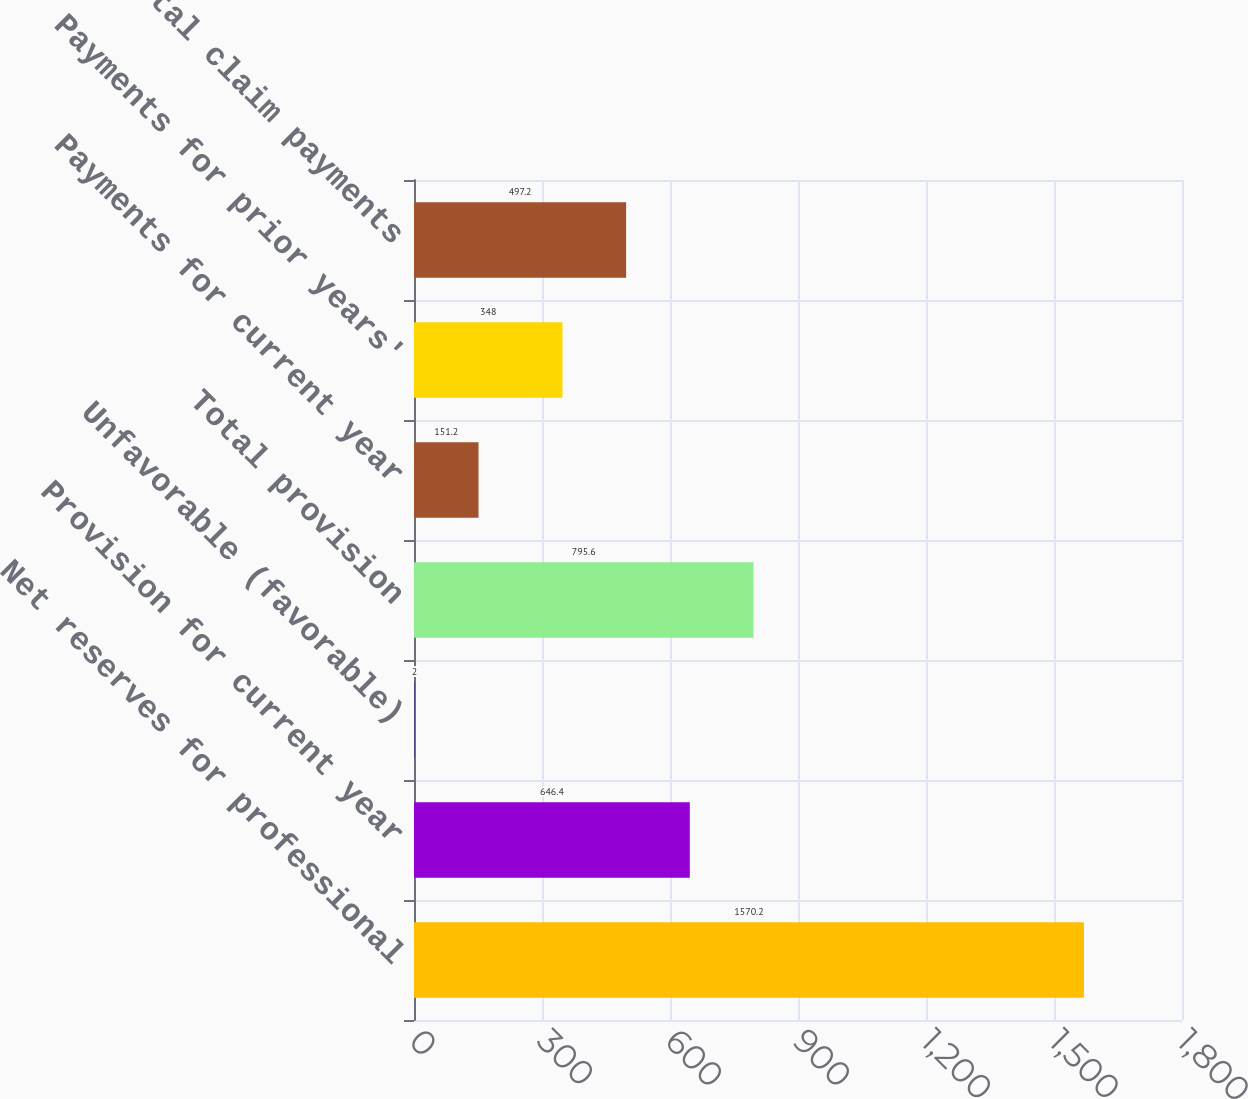Convert chart. <chart><loc_0><loc_0><loc_500><loc_500><bar_chart><fcel>Net reserves for professional<fcel>Provision for current year<fcel>Unfavorable (favorable)<fcel>Total provision<fcel>Payments for current year<fcel>Payments for prior years'<fcel>Total claim payments<nl><fcel>1570.2<fcel>646.4<fcel>2<fcel>795.6<fcel>151.2<fcel>348<fcel>497.2<nl></chart> 